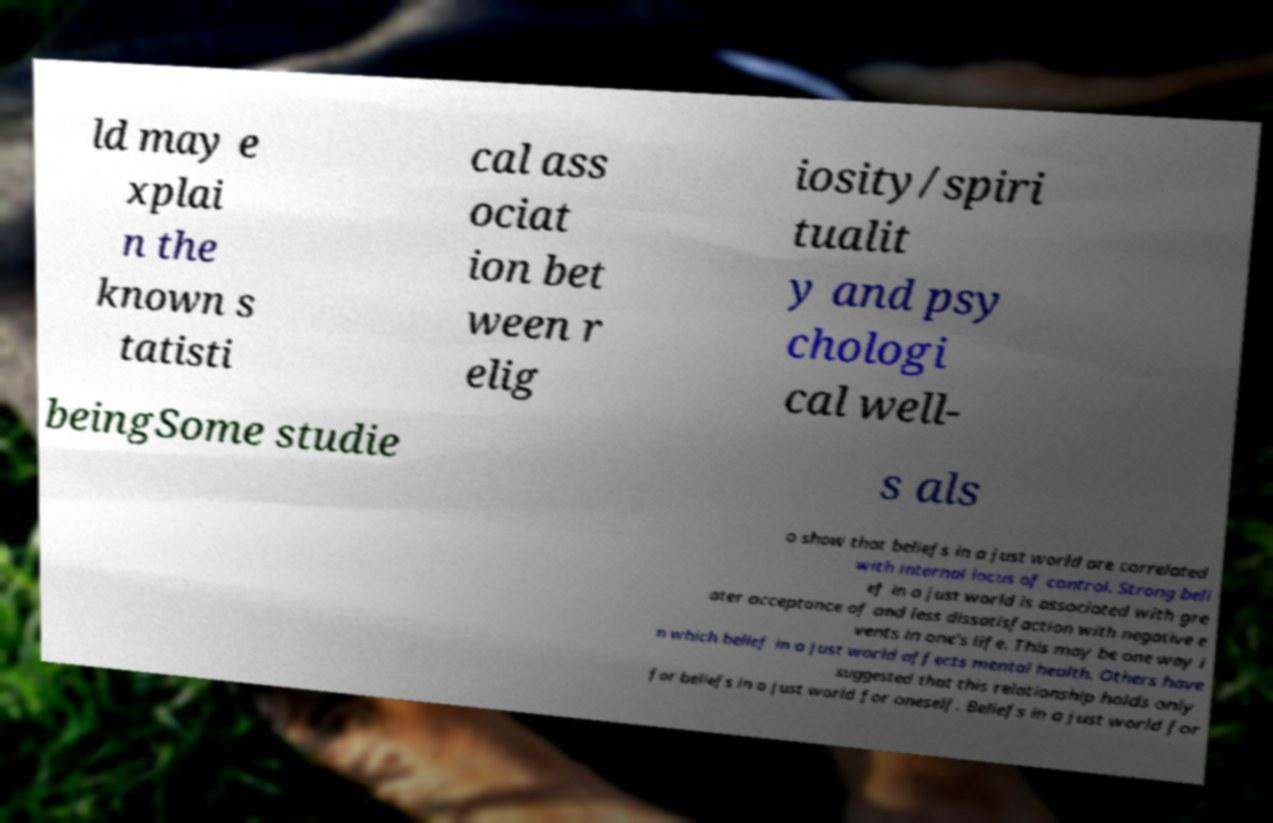I need the written content from this picture converted into text. Can you do that? ld may e xplai n the known s tatisti cal ass ociat ion bet ween r elig iosity/spiri tualit y and psy chologi cal well- beingSome studie s als o show that beliefs in a just world are correlated with internal locus of control. Strong beli ef in a just world is associated with gre ater acceptance of and less dissatisfaction with negative e vents in one's life. This may be one way i n which belief in a just world affects mental health. Others have suggested that this relationship holds only for beliefs in a just world for oneself. Beliefs in a just world for 